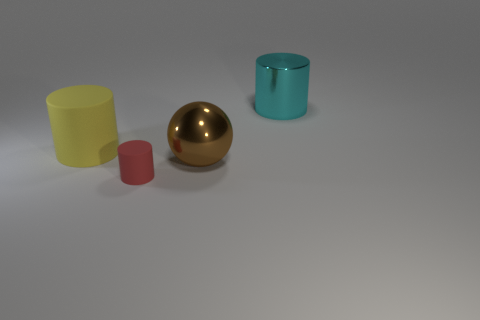Is there any other thing that is the same size as the red rubber object?
Keep it short and to the point. No. Are there fewer red rubber things than large metallic things?
Your response must be concise. Yes. The thing that is both behind the brown sphere and in front of the large cyan metallic object is made of what material?
Ensure brevity in your answer.  Rubber. There is a object in front of the large brown thing; is there a big yellow thing that is behind it?
Your response must be concise. Yes. What number of things are tiny cylinders or metal spheres?
Ensure brevity in your answer.  2. There is a big object that is behind the ball and on the left side of the big metal cylinder; what shape is it?
Your response must be concise. Cylinder. Are the object on the left side of the tiny object and the tiny cylinder made of the same material?
Provide a succinct answer. Yes. What number of things are red rubber objects or objects on the left side of the cyan metallic object?
Provide a short and direct response. 3. There is another cylinder that is made of the same material as the yellow cylinder; what color is it?
Give a very brief answer. Red. How many tiny cylinders have the same material as the tiny thing?
Ensure brevity in your answer.  0. 